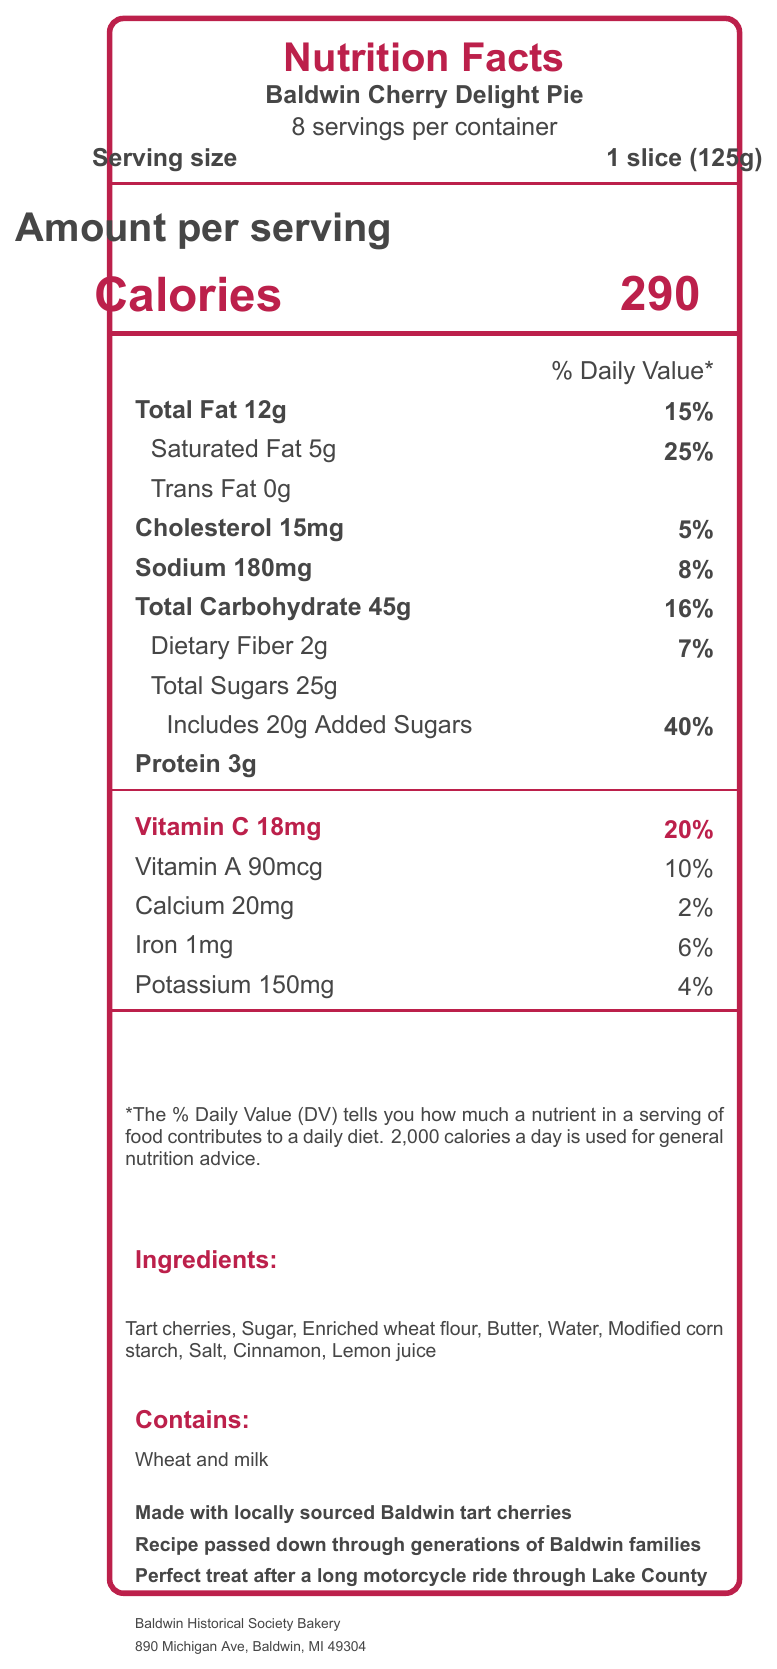what is the product name? The product name is explicitly mentioned at the top of the document, right below the title "Nutrition Facts".
Answer: Baldwin Cherry Delight Pie what is the serving size for this pie? The serving size is listed near the top of the document, indicating one slice (125g).
Answer: 1 slice (125g) how many servings are there per container? The document specifies that there are 8 servings per container, which is located below the product name.
Answer: 8 what percentage of the daily value of vitamin C does one serving contain? The document states that one serving contains 18mg of vitamin C, which is 20% of the daily value.
Answer: 20% how many calories are in one serving? The document clearly shows that one serving of the pie contains 290 calories.
Answer: 290 what is the percentage of the daily value of cholesterol in one serving? According to the document, one serving provides 15mg of cholesterol, which is 5% of the daily value.
Answer: 5% which ingredient is listed first in the ingredients list? The document specifies "Tart cherries" as the first ingredient in the list.
Answer: Tart cherries how much total fat is in one serving? The document lists the total fat content per serving as 12g.
Answer: 12g how much sodium does one serving contain? The sodium content per serving is indicated as 180mg in the document.
Answer: 180mg how many grams of dietary fiber are there in a serving? The document states that each serving contains 2g of dietary fiber.
Answer: 2g what is the address of the manufacturer? The address of the manufacturer, Baldwin Historical Society Bakery, is provided at the bottom of the document.
Answer: 890 Michigan Ave, Baldwin, MI 49304 what percentage of the daily value of added sugars does one serving contain? The document indicates that the pie has 20g of added sugars, which is 40% of the daily value.
Answer: 40% contains the pie any allergens? if so, what are they? The document mentions that the pie contains wheat and milk as allergens.
Answer: Yes, wheat and milk how much protein is in one serving of the pie? The document states that one serving contains 3g of protein.
Answer: 3g what is the main ingredient in the Baldwin Cherry Delight Pie? A. Sugar B. Enriched wheat flour C. Tart cherries D. Butter The ingredients list starts with "Tart cherries", indicating it is the main ingredient.
Answer: C. Tart cherries how much cholesterol is in a single serving of the pie? A. 10mg B. 15mg C. 20mg D. 25mg The document lists the cholesterol content for one serving as 15mg.
Answer: B. 15mg does the Baldwin Cherry Delight Pie include any information about its source of cherries? The document states that the pie is made with locally sourced Baldwin tart cherries.
Answer: Yes is the recipe for the Baldwin Cherry Delight Pie passed down through generations of Baldwin families? The document mentions that the recipe has been passed down through generations of Baldwin families.
Answer: Yes summarize the main idea of the document. The document is essentially the nutrition facts label for the Baldwin Cherry Delight Pie, offering a breakdown of its nutritional content, ingredients, and some historical context.
Answer: The document provides the nutritional information for the Baldwin Cherry Delight Pie, along with details about the ingredients, allergens, and additional information about the local sourcing of cherries and the historical aspect of the recipe. how much trans fat is in one serving of the pie? The document lists the trans fat content as 0g, meaning there is no trans fat in one serving of the pie.
Answer: Cannot be determined explain why Baldwin Cherry Delight Pie can be considered a good source of vitamin C. The document clearly states that one serving has 18mg of vitamin C, and given that this represents 20% of the daily value, it underscores the pie's high vitamin C content.
Answer: One serving of the Baldwin Cherry Delight Pie contains 18mg of vitamin C, which is 20% of the daily value. This means that the pie contributes a significant amount of vitamin C, making it a good source. 